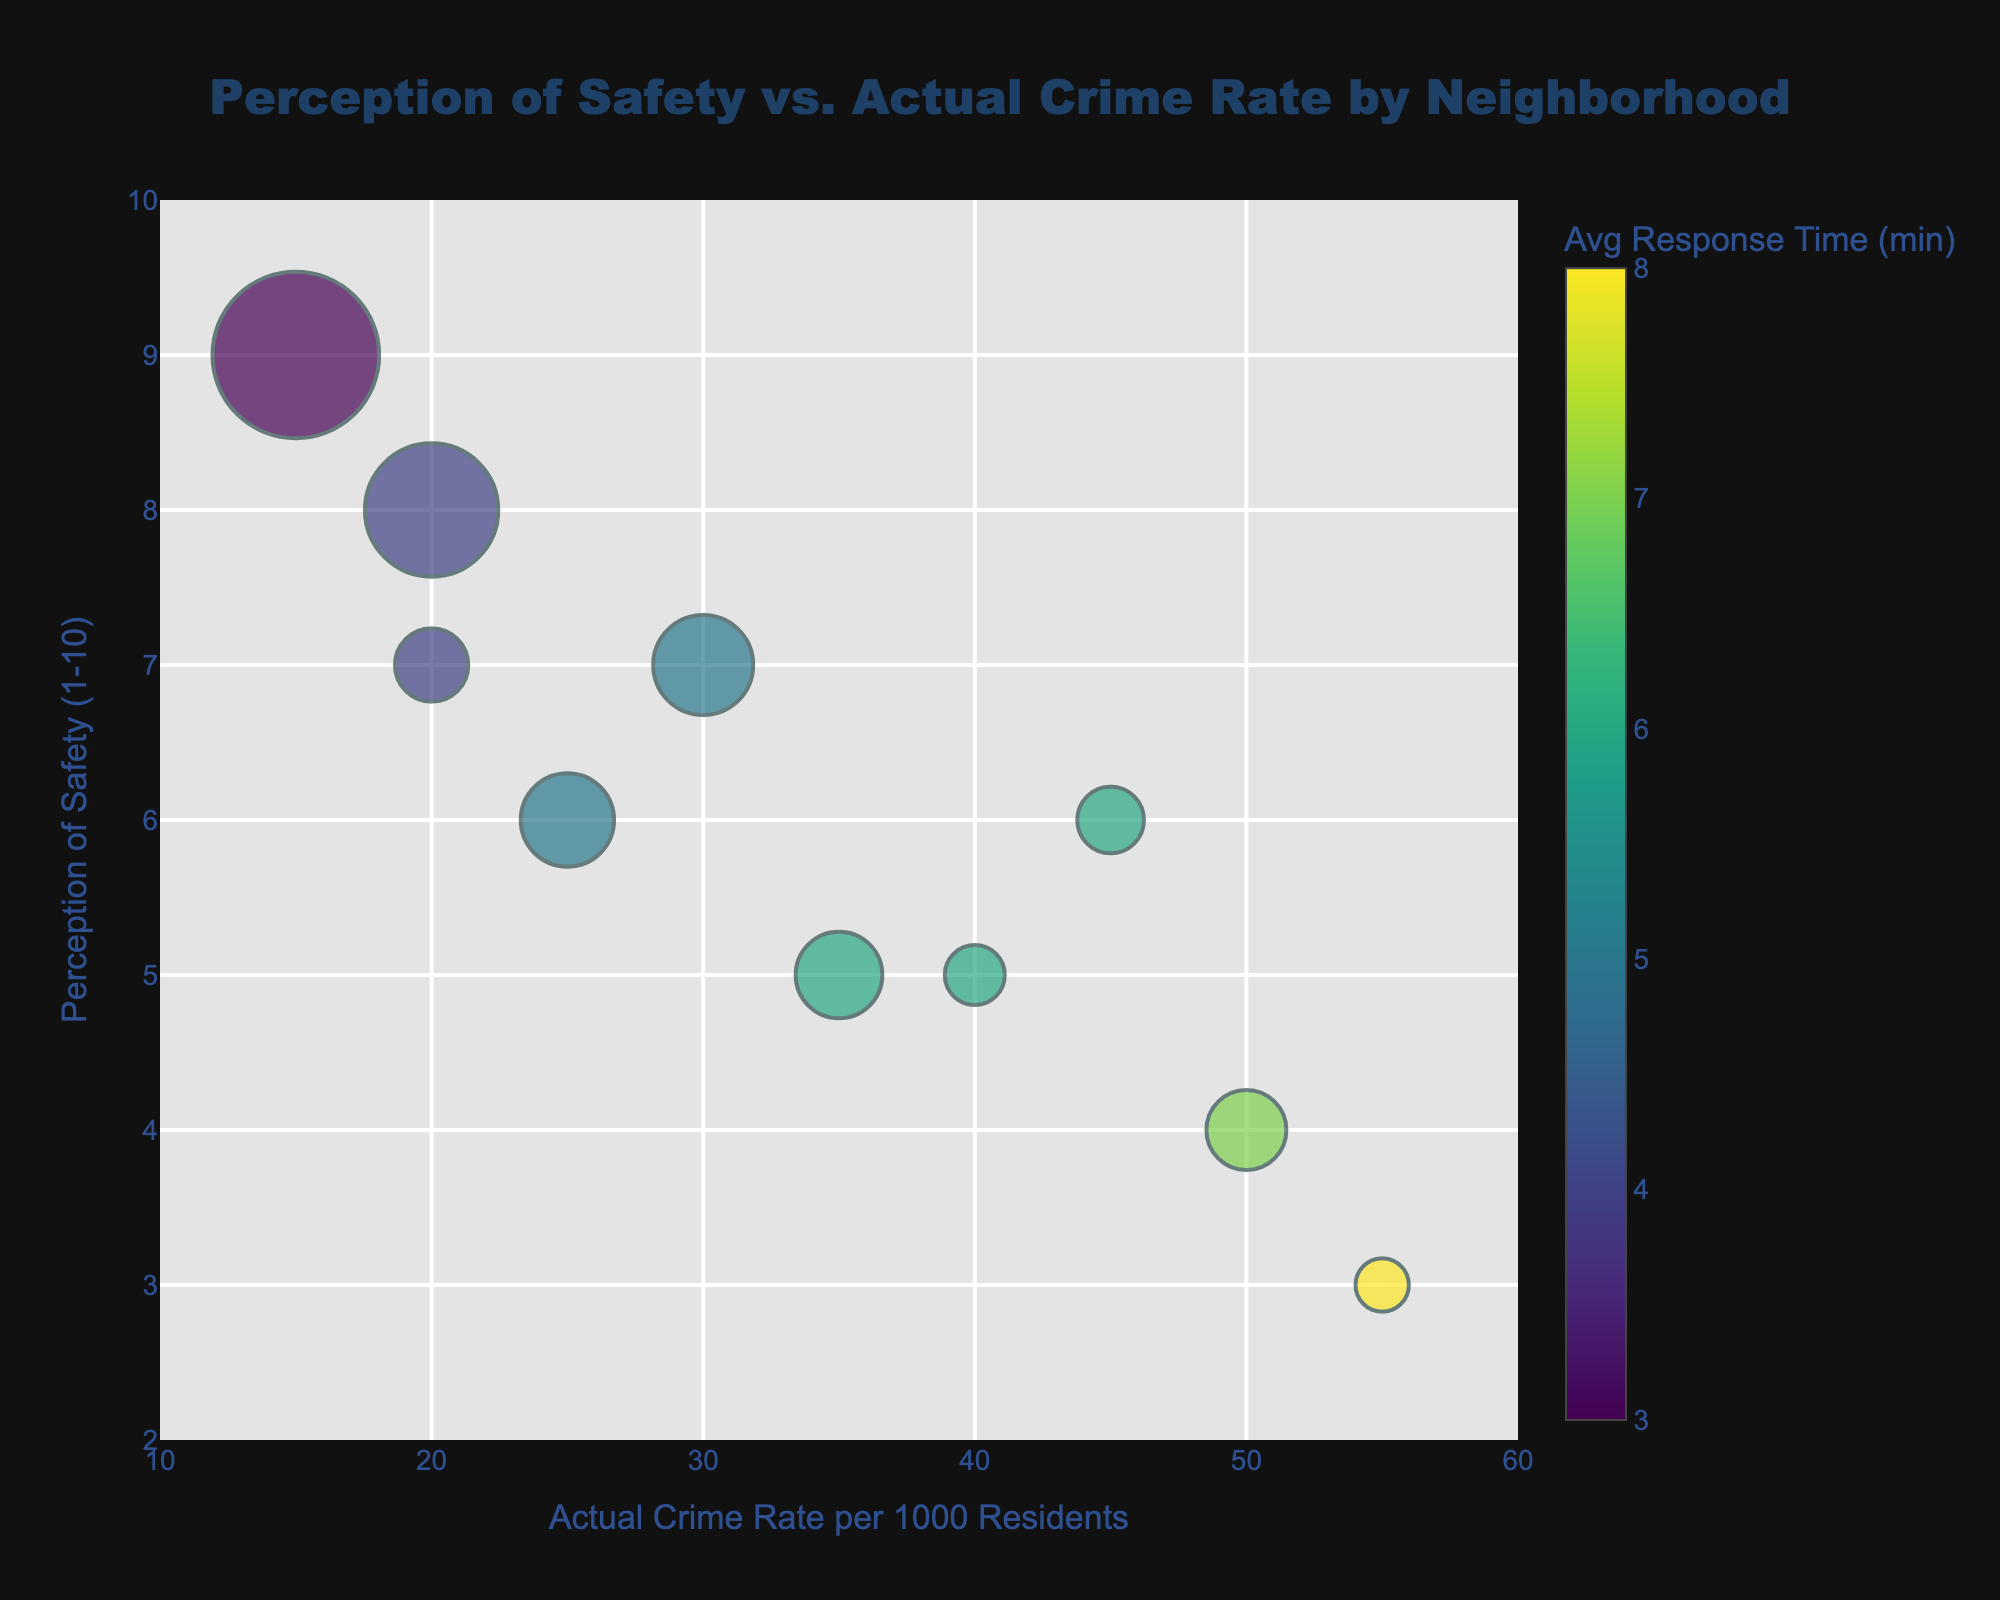How many neighborhoods are represented in the figure? Count the number of unique neighborhoods listed in the data points. There are 10 neighborhoods: Downtown, Uptown, Suburbia, Riverside, Old Town, University District, Hillcrest, West End, East Side, Central Park.
Answer: 10 Which neighborhood has the highest actual crime rate? Look for the highest value on the x-axis representing the actual crime rate per 1000 residents. It is Old Town with a crime rate of 55.
Answer: Old Town What is the perception of safety for the Downtown neighborhood? Locate 'Downtown' in the data and identify the corresponding perception of safety value on the y-axis, which is 4.
Answer: 4 Which neighborhood has the largest bubble size, indicating the largest population? Compare the bubble sizes visually, Hillcrest has the largest bubble which indicates the largest population.
Answer: Hillcrest What is the average response time for Uptown? Look at the color scale which represents the average response time and identify the value for Uptown. The color indicates an average response time of 5 minutes.
Answer: 5 minutes Which neighborhood has a perception of safety greater than 7 and an actual crime rate less than 20? Filter the data to find neighborhoods meeting both conditions; Hillcrest with a safety perception of 9 and actual crime rate of 15, and Suburbia with safety perception of 8 and actual crime rate of 20, both satisfy the conditions.
Answer: Hillcrest and Suburbia Which neighborhood has the biggest discrepancy between perception of safety and actual crime rate? Calculate the absolute difference between the perception of safety and actual crime rate for each neighborhood. Old Town has the greatest discrepancy:
Answer: Old Town Compare the safety perception of University District to Riverside Look at the y-axis values for University District (5) and Riverside (6), Riverside has a higher perception of safety.
Answer: Riverside Do higher population neighborhoods generally have better safety perceptions? Observe the sizes of the bubbles and their positions on the y-axis. Hillcrest and Suburbia, with larger populations, have higher safety perceptions, suggesting a general positive correlation.
Answer: Generally, yes Which neighborhood has an average response time of 3 minutes? Identify the bubble with the color belonging to the lowest value of 3 minutes in the color scale, it is Hillcrest.
Answer: Hillcrest 